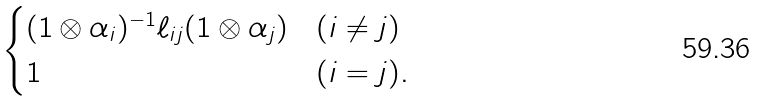<formula> <loc_0><loc_0><loc_500><loc_500>\begin{cases} ( 1 \otimes \alpha _ { i } ) ^ { - 1 } \ell _ { i j } ( 1 \otimes \alpha _ { j } ) & ( i \neq j ) \\ 1 & ( i = j ) . \end{cases}</formula> 